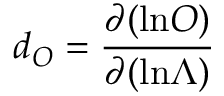<formula> <loc_0><loc_0><loc_500><loc_500>d _ { O } = { \frac { \partial ( \ln O ) } { \partial ( \ln \Lambda ) } }</formula> 